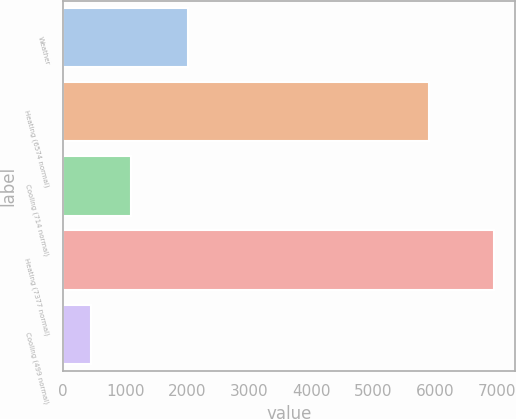<chart> <loc_0><loc_0><loc_500><loc_500><bar_chart><fcel>Weather<fcel>Heating (6574 normal)<fcel>Cooling (714 normal)<fcel>Heating (7377 normal)<fcel>Cooling (499 normal)<nl><fcel>2017<fcel>5908<fcel>1099.2<fcel>6942<fcel>450<nl></chart> 